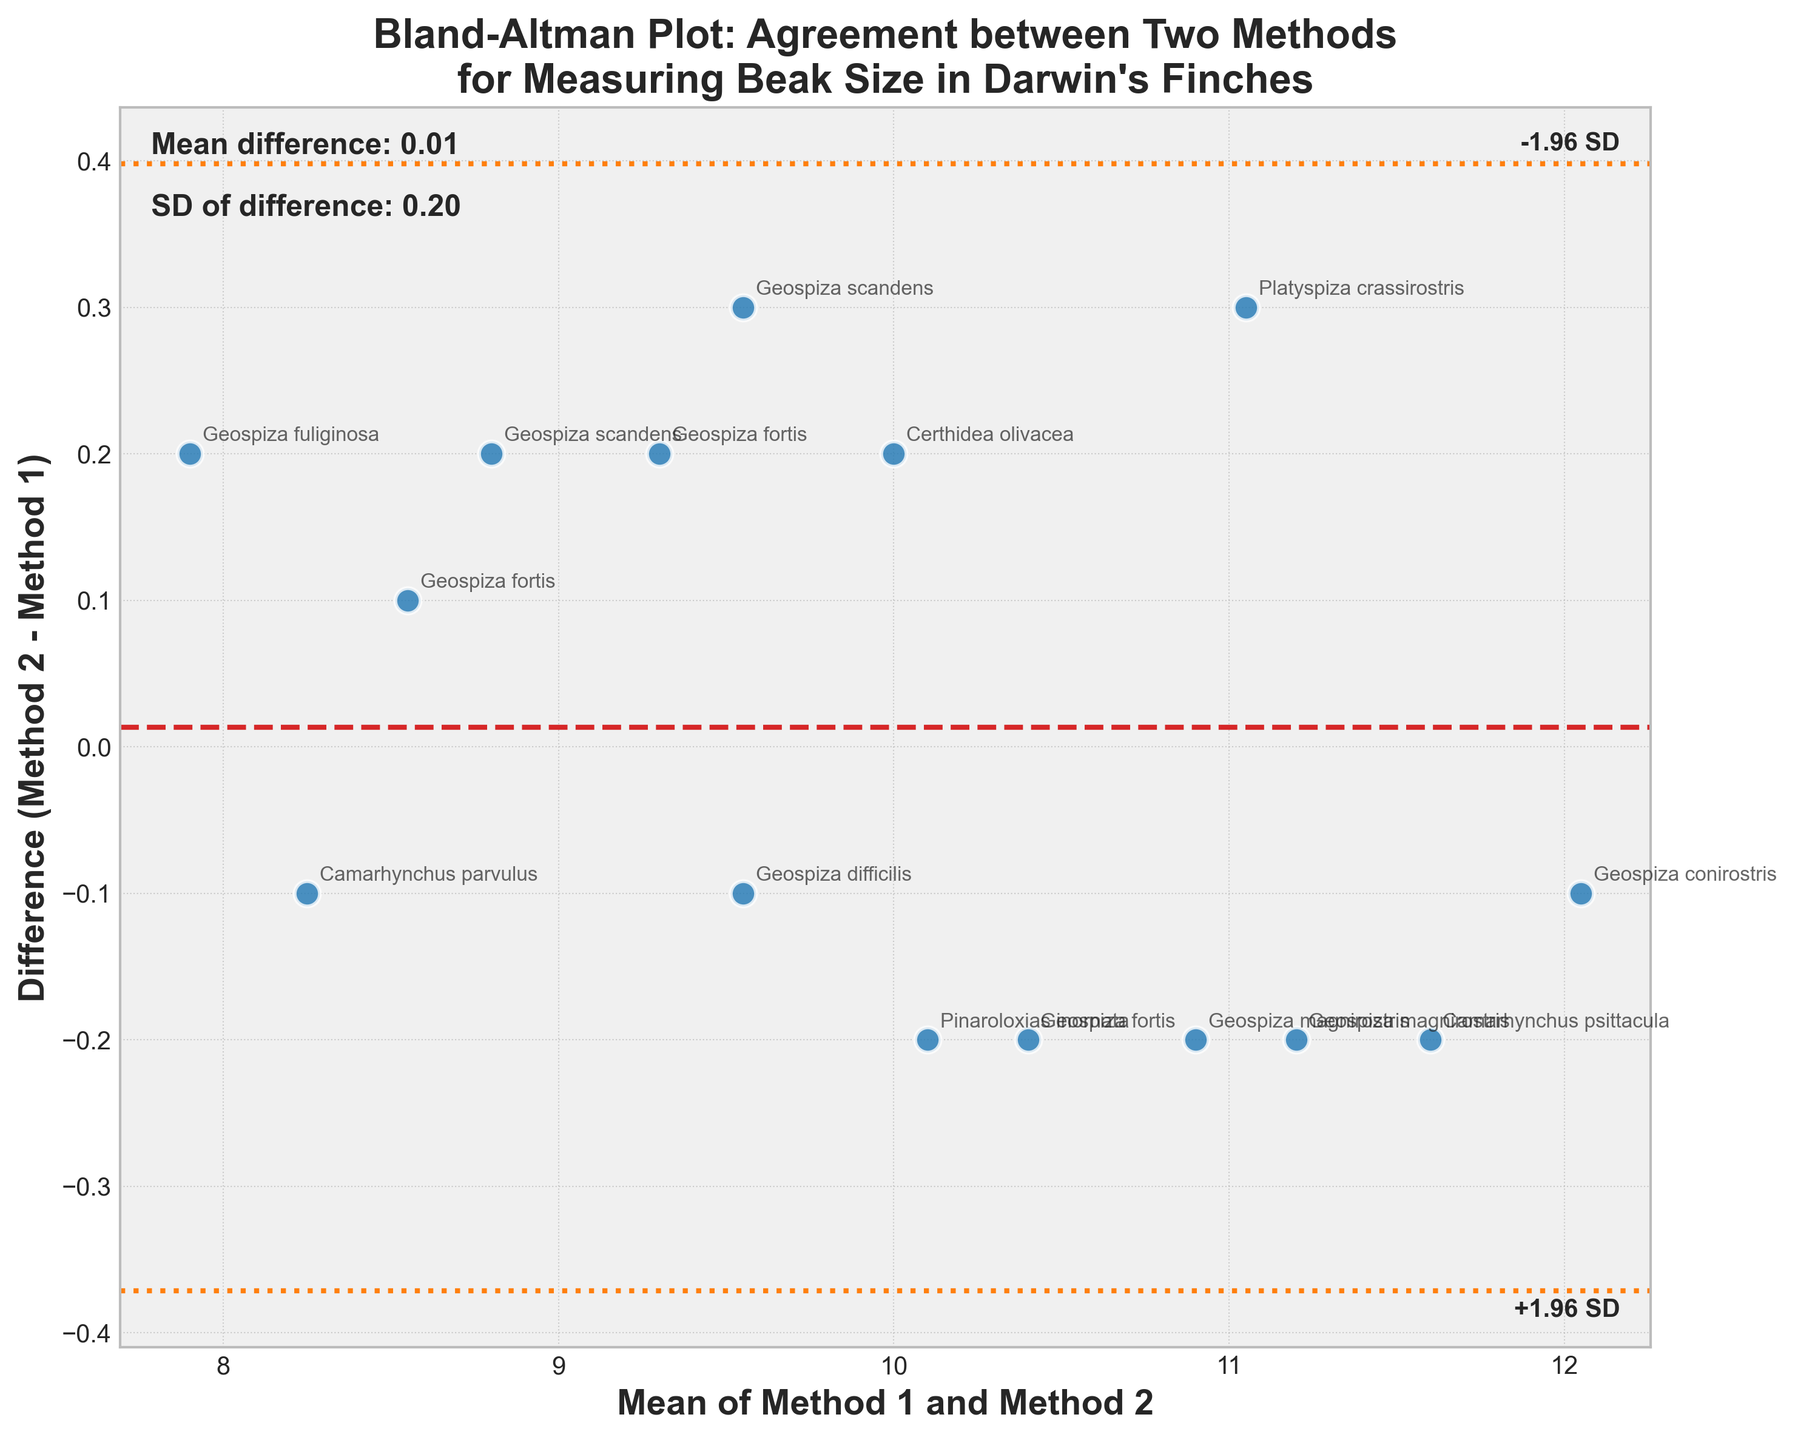How many data points are shown in the plot? Count the number of labeled points on the plot. Each species name indicates a data point, and there are 15 distinct species names on the plot.
Answer: 15 What is the title of the plot? The title is prominently displayed at the top of the plot.
Answer: Bland-Altman Plot: Agreement between Two Methods for Measuring Beak Size in Darwin's Finches What do the horizontal dashed red and dotted orange lines represent? The dashed red line represents the mean difference between Method 2 and Method 1, and the dotted orange lines represent the mean difference plus and minus 1.96 times the standard deviation.
Answer: Mean difference and ±1.96 SD lines Which point indicates the smallest difference between Method 2 and Method 1? Identify the point closest to the horizontal line where the difference is zero. This is the point representing Certhidea olivacea.
Answer: Certhidea olivacea What is the mean of the differences between Method 2 and Method 1? This is indicated by the dashed red line. According to the plot, the mean difference is around 0.03, which matches the text annotation.
Answer: 0.03 Which species had the largest beak size measurement difference between the two methods? Find the point that is furthest from the horizontal line on the plot. Geospiza scandens has the largest positive difference.
Answer: Geospiza scandens What is the standard deviation of the differences between Method 2 and Method 1? This information is provided in the text annotations on the plot. The annotation states the SD of the difference is approximately 0.40.
Answer: 0.40 Which species has the highest mean beak size measurement from the two methods? Locate the point with the highest x-value (mean of Method 1 and Method 2). This is Geospiza conirostris with a mean beak size around 12.05.
Answer: Geospiza conirostris How many species showed a Method 2 measurement that was greater than Method 1? Count the number of points above the dashed red line (mean difference). There are 9 data points above the line.
Answer: 9 